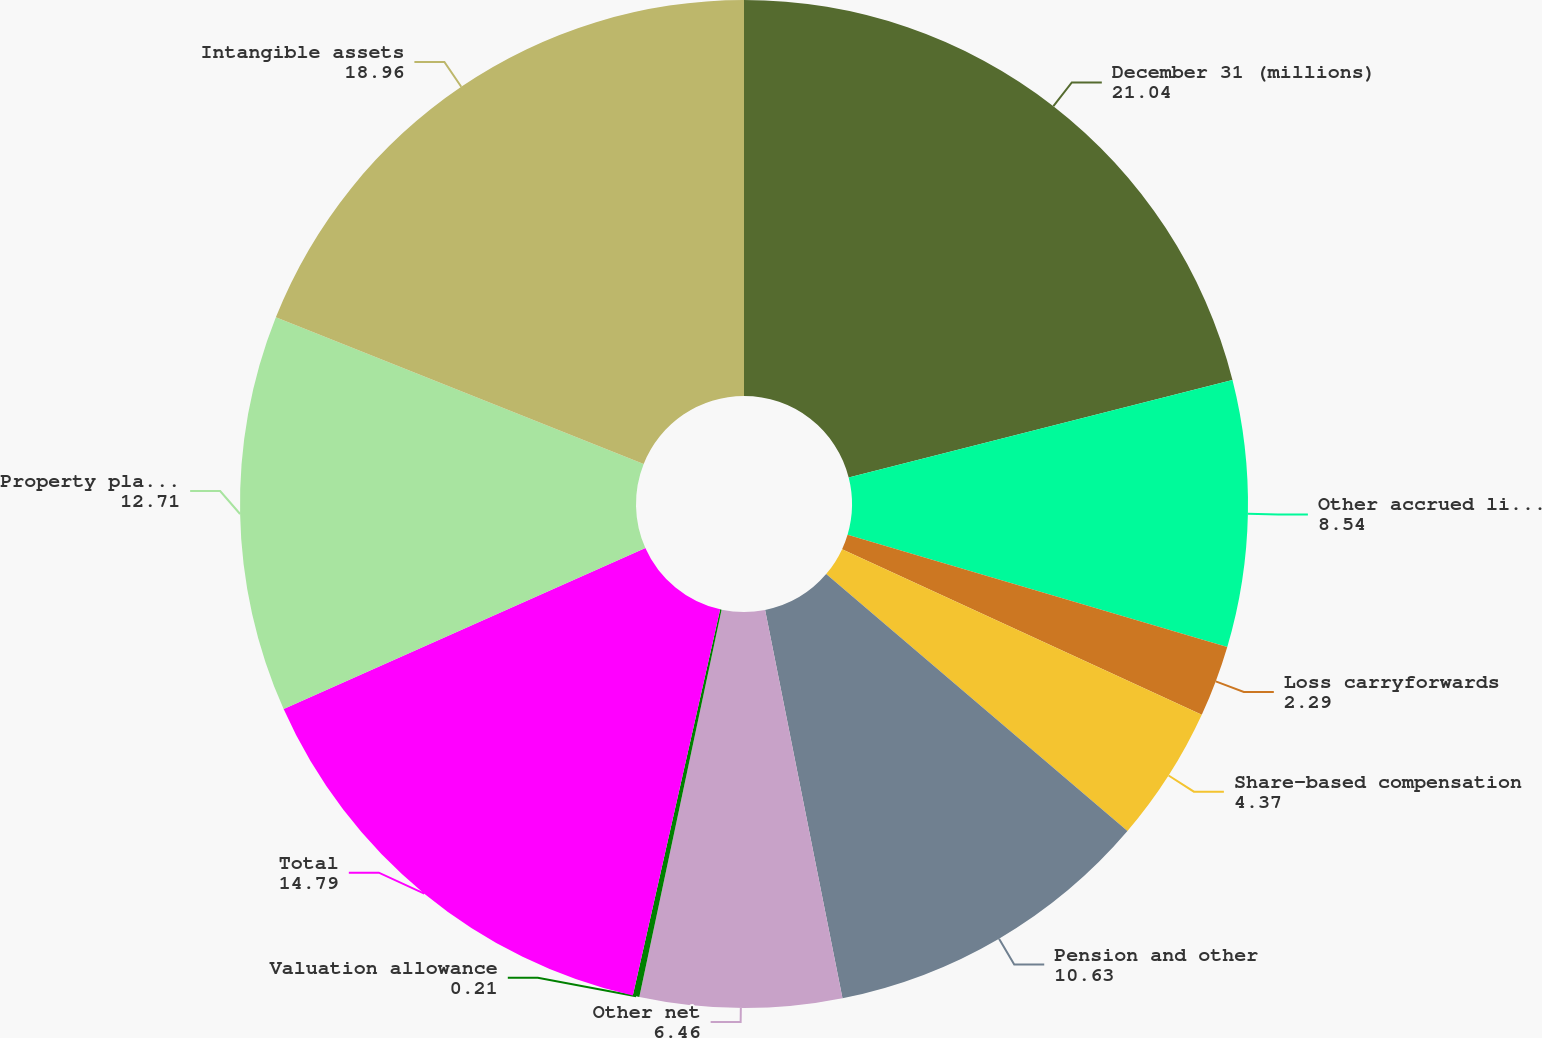Convert chart to OTSL. <chart><loc_0><loc_0><loc_500><loc_500><pie_chart><fcel>December 31 (millions)<fcel>Other accrued liabilities<fcel>Loss carryforwards<fcel>Share-based compensation<fcel>Pension and other<fcel>Other net<fcel>Valuation allowance<fcel>Total<fcel>Property plant and equipment<fcel>Intangible assets<nl><fcel>21.04%<fcel>8.54%<fcel>2.29%<fcel>4.37%<fcel>10.63%<fcel>6.46%<fcel>0.21%<fcel>14.79%<fcel>12.71%<fcel>18.96%<nl></chart> 